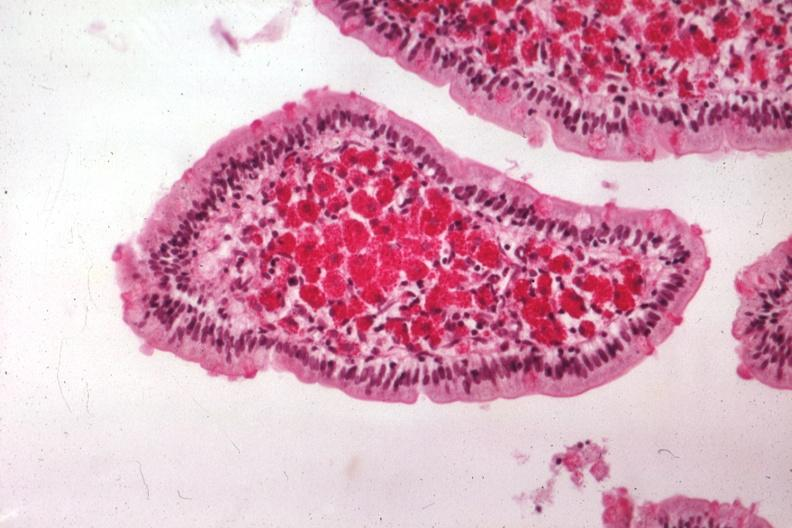s whipples disease present?
Answer the question using a single word or phrase. Yes 